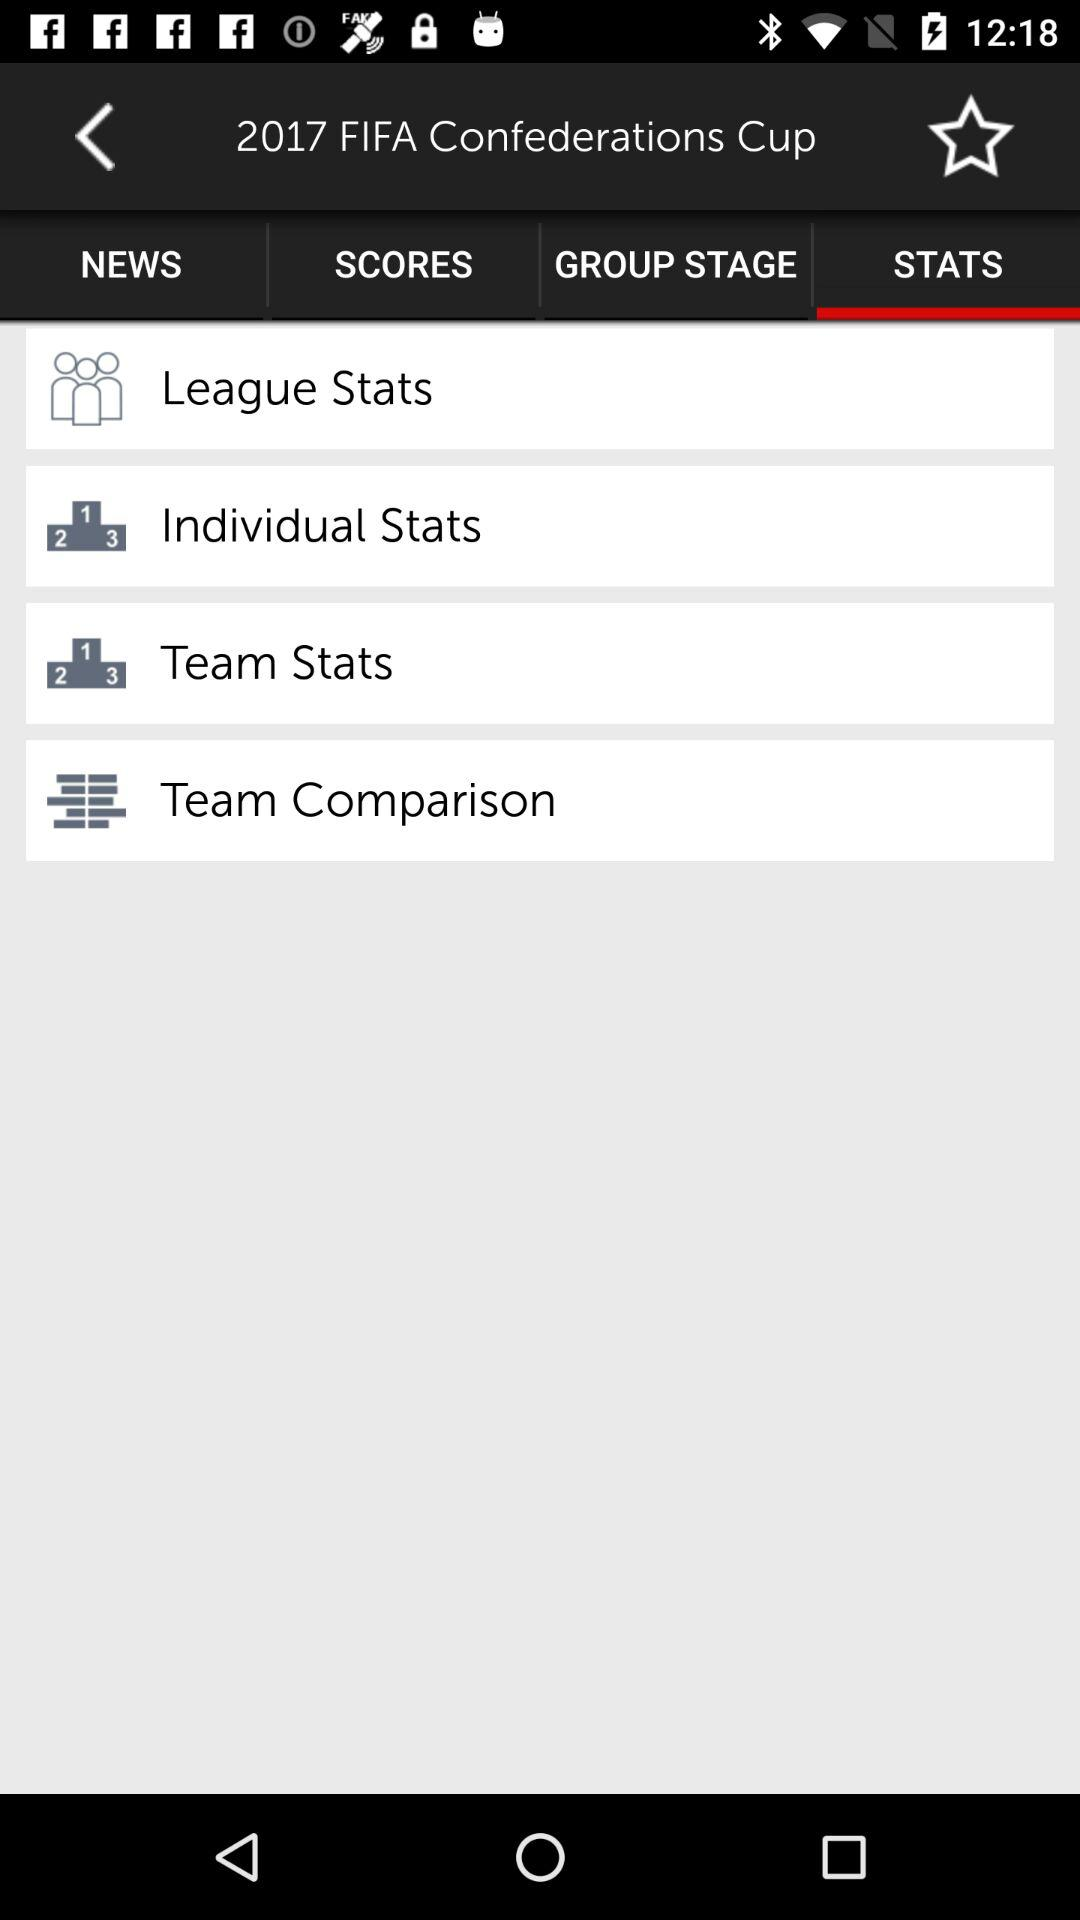Which tab is selected? The selected tab is "STATS". 